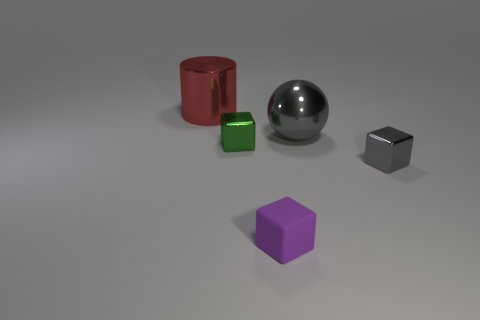Add 4 spheres. How many objects exist? 9 Subtract all cylinders. How many objects are left? 4 Subtract 0 red cubes. How many objects are left? 5 Subtract all large brown rubber cylinders. Subtract all tiny green cubes. How many objects are left? 4 Add 2 big red metallic objects. How many big red metallic objects are left? 3 Add 1 large metallic cylinders. How many large metallic cylinders exist? 2 